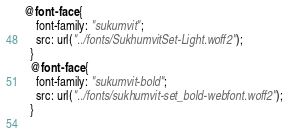<code> <loc_0><loc_0><loc_500><loc_500><_CSS_>@font-face {
    font-family: "sukumvit";
    src: url("../fonts/SukhumvitSet-Light.woff2");
  }
  @font-face {
    font-family: "sukumvit-bold";
    src: url("../fonts/sukhumvit-set_bold-webfont.woff2");
  }
  
</code> 